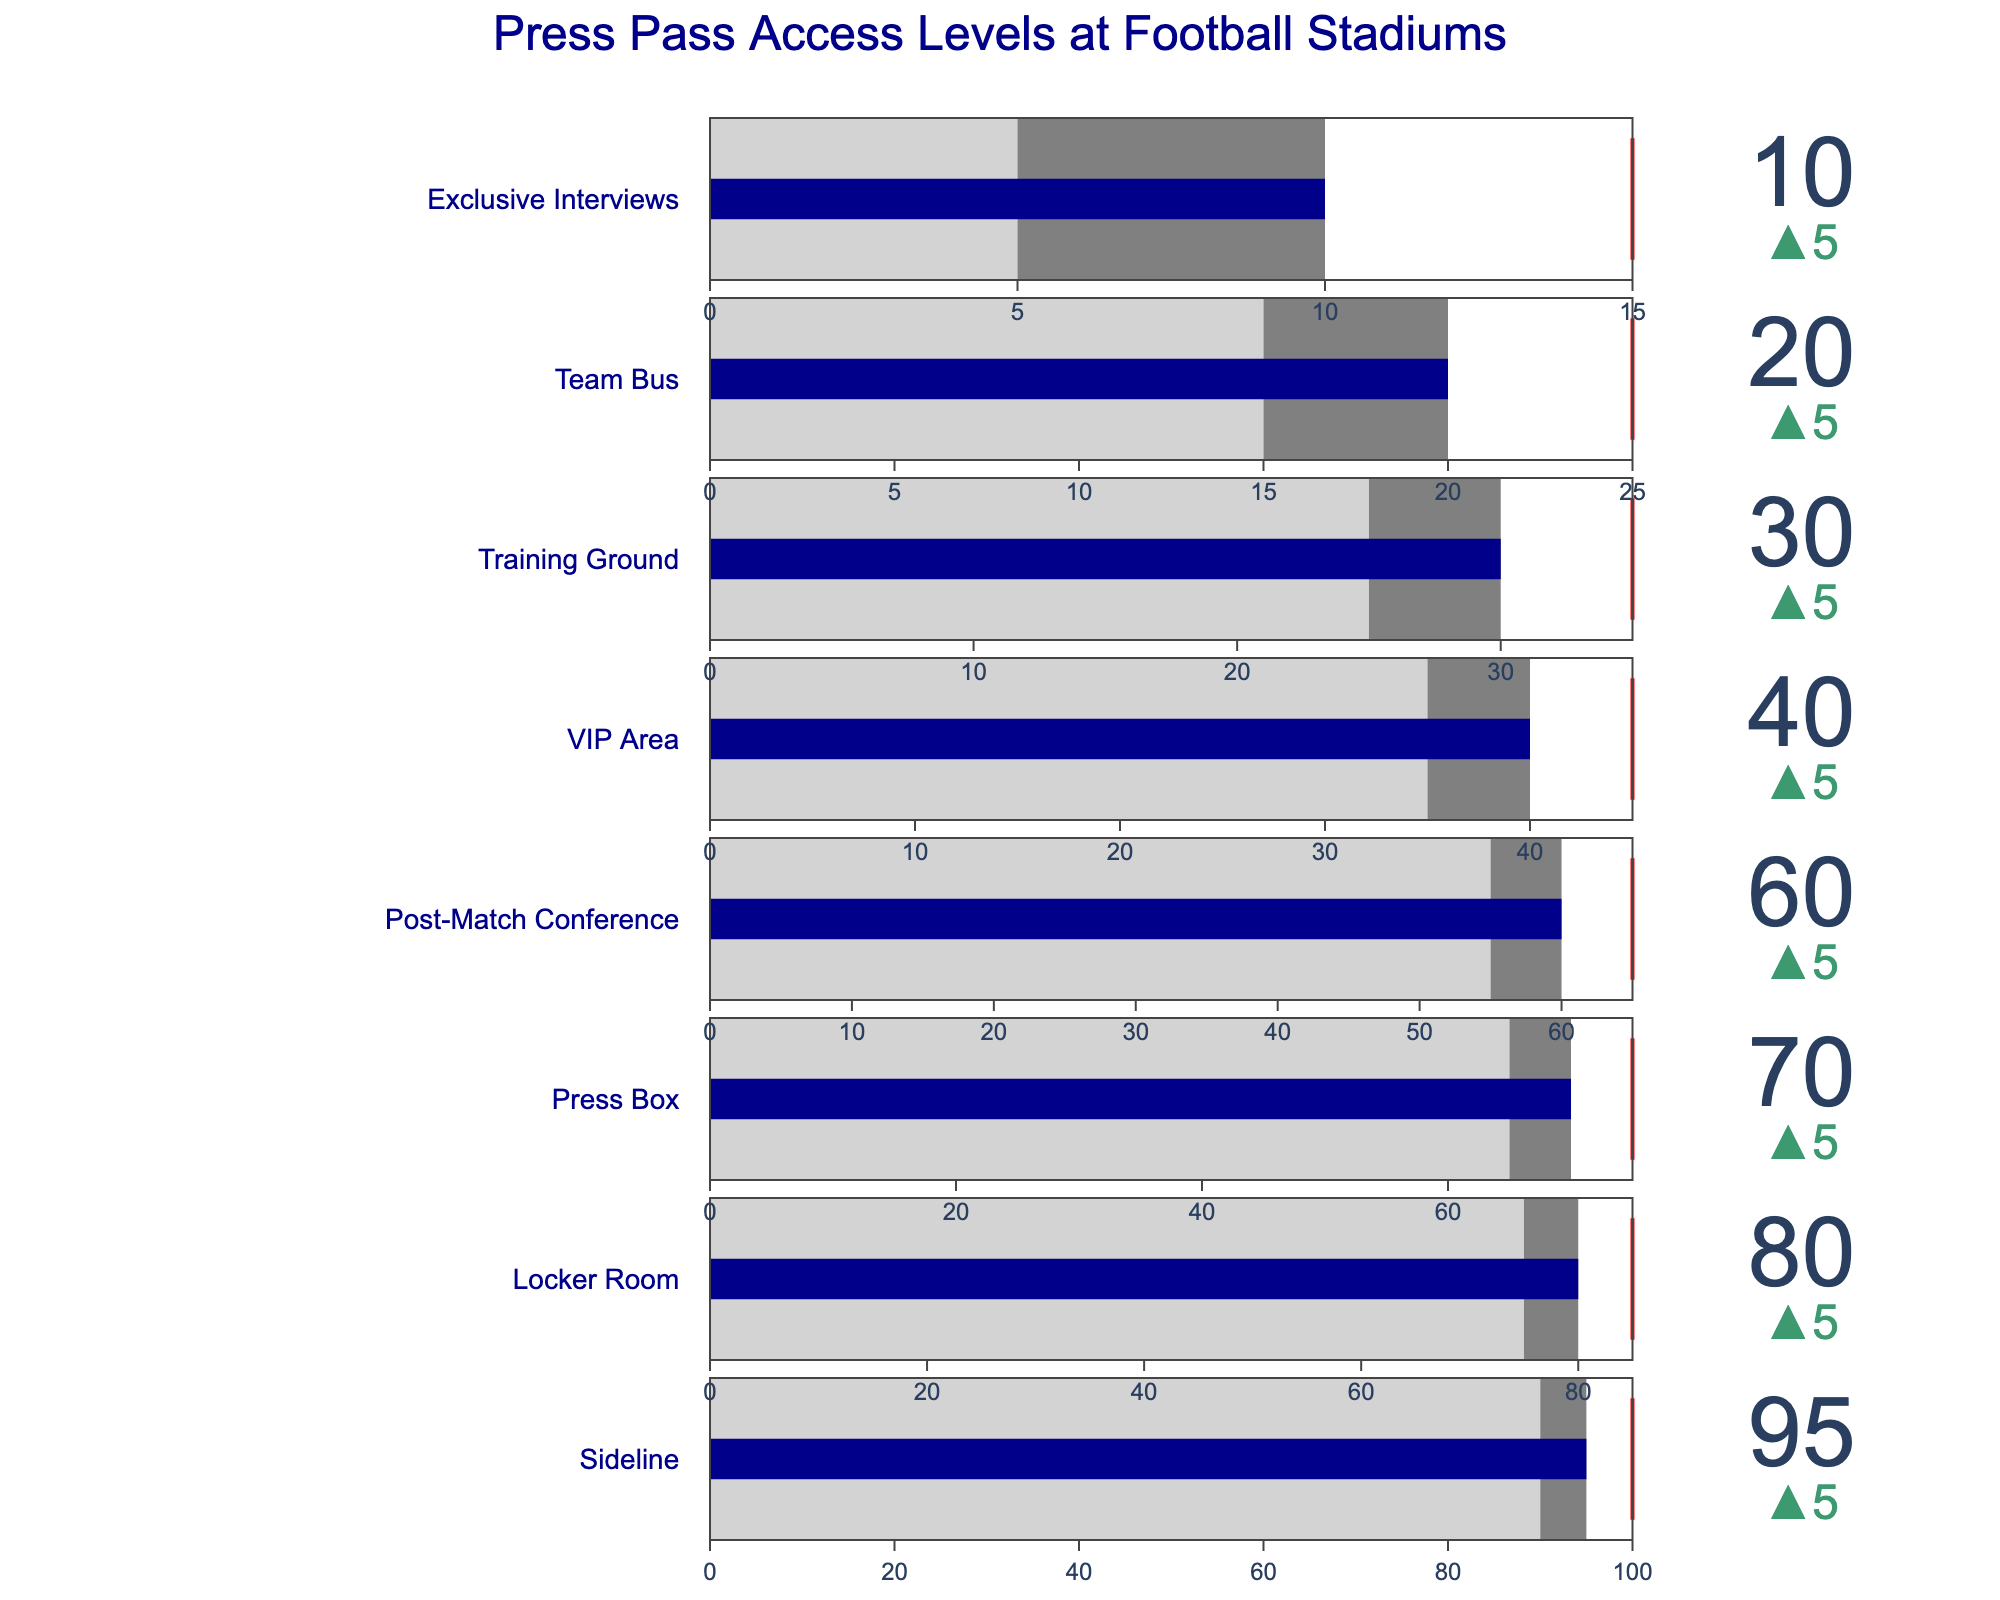What's the title of the figure? The title of a figure is typically placed at the top and provides an overview of what the data represents. In this case, it's clearly stated at the top.
Answer: Press Pass Access Levels at Football Stadiums How many access levels are displayed in the figure? By counting the number of bullet charts representing different access levels, we see that each row corresponds to a specific access level.
Answer: 8 Which access level has the highest current value? The highest current value can be identified by looking at the lengths of the dark blue bars for each access level. The longest bar indicates the highest value.
Answer: Sideline What's the current value for the Team Bus access level? Referring to the specific bullet chart labeled "Team Bus" and checking the number displayed within it gives us the current value.
Answer: 20 Which access level has the smallest difference between its current and target values? By comparing the gaps between the end of the dark blue bars (current values) and the red lines (target values), we find the smallest difference.
Answer: Post-Match Conference Order the access levels by their level of exclusivity, starting with the most exclusive. To determine exclusivity, we look at the level names since some levels inherently have restricted access. Typically, Exclusive Interviews would be the most exclusive, followed by Team Bus, and so on.
Answer: Exclusive Interviews, Team Bus, Training Ground, VIP Area, Post-Match Conference, Press Box, Locker Room, Sideline What's the comparative value for the Press Box access level? For the Press Box access level, we locate its specific bullet chart and check the left end of the light gray bar which represents the comparative value.
Answer: 65 Which access level has the largest increase from its comparative to its current value? Compare the differences between the left and right ends of the light gray bars (comparative values) and dark blue bars (current values) to see which has the largest increase.
Answer: Sideline How does the Locker Room's current value compare to its target value? Look at the dark blue bar (current value) and the red threshold line (target value) in the Locker Room's bullet chart to compare.
Answer: It's 5 units below the target Calculate the average current value of all the access levels. Sum all the current values (95 + 80 + 70 + 60 + 40 + 30 + 20 + 10) and divide by the number of access levels (8). (95 + 80 + 70 + 60 + 40 + 30 + 20 + 10) / 8 = 50.6
Answer: 50.6 